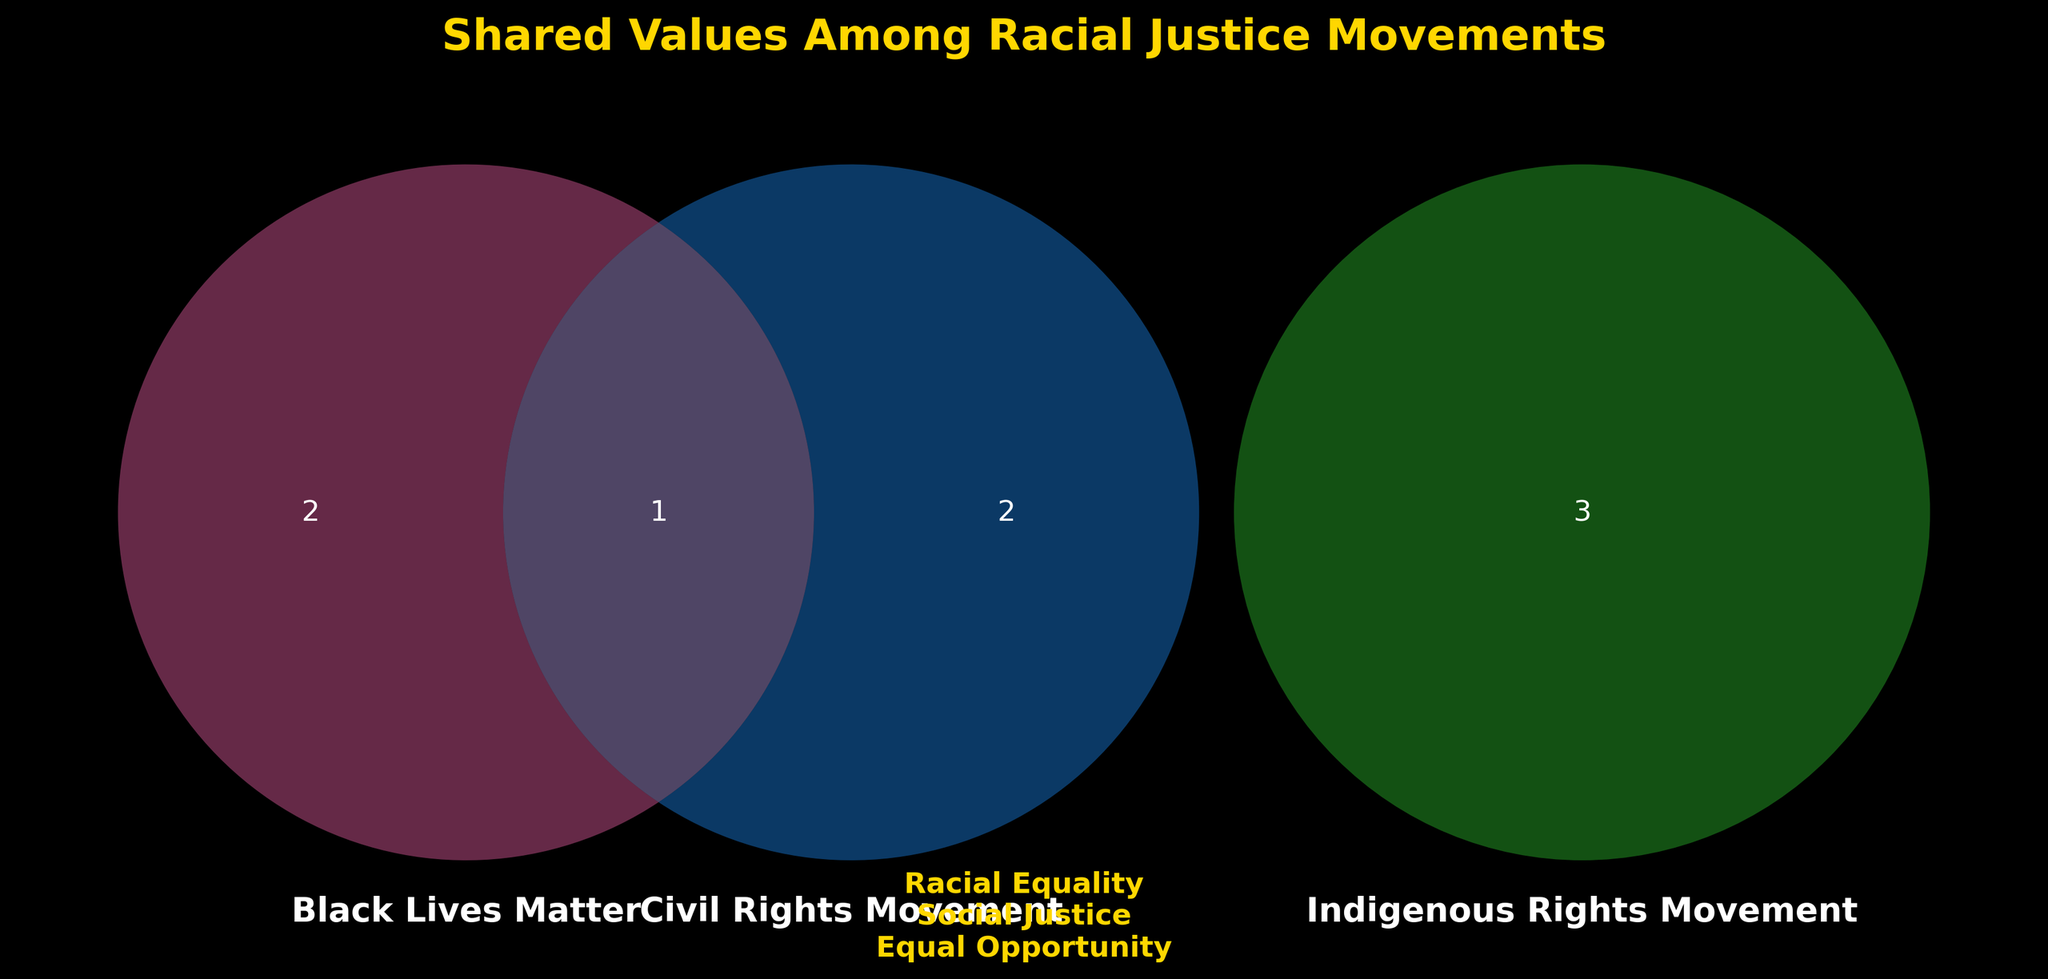What is the title of the figure? The title of the figure is displayed at the top. It reads, "Shared Values Among Racial Justice Movements."
Answer: Shared Values Among Racial Justice Movements Which color represents "Black Lives Matter"? "Black Lives Matter" is represented by the pinkish region in the Venn diagram.
Answer: Pinkish Which value is shared by all three movements? The central overlapping area where all three circles intersect represents values shared by all movements; "Racial Equality" is in this intersection.
Answer: Racial Equality How many unique values are represented by the Indigenous Rights Movement? Look at Indigenous Rights Movement's circle and count all unique values within it, both exclusive and shared sections. Values include "Land Rights," "Cultural Preservation," and "Environmental Justice." So, there are 3 unique values.
Answer: 3 Which movement has "Voting Rights" as a unique value? "Voting Rights" appears in the section of the Venn diagram exclusively for the Civil Rights Movement, without overlapping with any other circles.
Answer: Civil Rights Movement Identify a value shared by Black Lives Matter and Civil Rights Movement but not Indigenous Rights Movement. Find the overlapping region between the circles of Black Lives Matter and Civil Rights Movement that does not include Indigenous Rights. That value is "Police Reform."
Answer: Police Reform What are common values among all movements other than "Racial Equality"? The common values shown under "All Movements" annotation are "Racial Equality," "Social Justice," and "Equal Opportunity." Excluding "Racial Equality" gives the remaining values.
Answer: Social Justice, Equal Opportunity Which movement shares the most values with the Civil Rights Movement based on the Venn diagram intersections? Look for the movement circle with the greatest overlapping area with the Civil Rights circle. Black Lives Matter overlaps more than Indigenous Rights Movement.
Answer: Black Lives Matter How does the size of the "Cultural Preservation" portion compare to "Educational Equity"? Based on the Venn diagram region sizes, "Cultural Preservation" falls within the Indigenous Rights circle, which appears smaller than the section for "Educational Equity" in the Civil Rights circle.
Answer: Smaller 